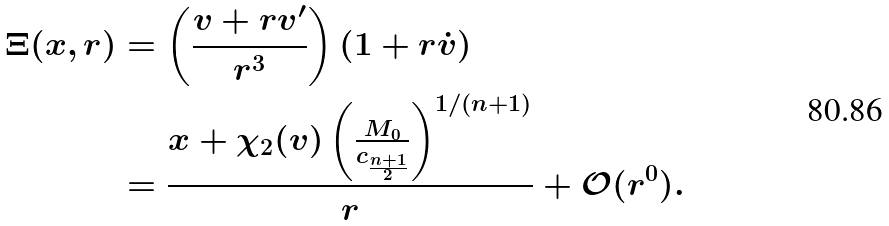Convert formula to latex. <formula><loc_0><loc_0><loc_500><loc_500>\Xi ( x , r ) & = \left ( \frac { v + r v ^ { \prime } } { r ^ { 3 } } \right ) \left ( 1 + r \dot { v } \right ) \\ & = \frac { x + \chi _ { 2 } ( v ) \left ( \frac { M _ { 0 } } { c _ { \frac { n + 1 } { 2 } } } \right ) ^ { 1 / ( n + 1 ) } } { r } + \mathcal { O } ( r ^ { 0 } ) .</formula> 